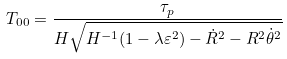<formula> <loc_0><loc_0><loc_500><loc_500>T _ { 0 0 } = \frac { \tau _ { p } } { H \sqrt { H ^ { - 1 } ( 1 - \lambda \varepsilon ^ { 2 } ) - \dot { R } ^ { 2 } - R ^ { 2 } \dot { \theta } ^ { 2 } } }</formula> 